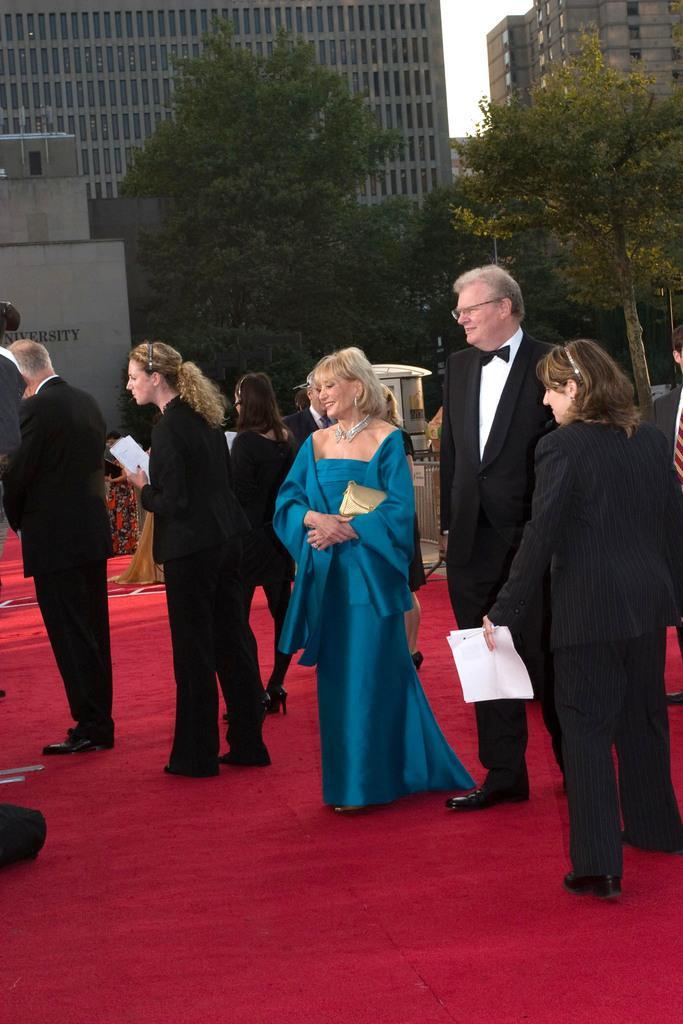Describe this image in one or two sentences. In this image there are group of people standing on the red carpet, and at the background there are trees, iron grills,buildings, sky. 